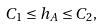Convert formula to latex. <formula><loc_0><loc_0><loc_500><loc_500>C _ { 1 } \leq h _ { A } \leq C _ { 2 } ,</formula> 